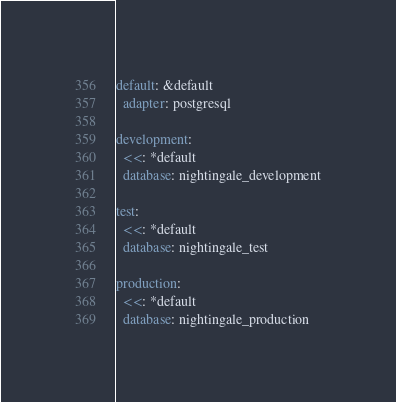Convert code to text. <code><loc_0><loc_0><loc_500><loc_500><_YAML_>default: &default
  adapter: postgresql

development:
  <<: *default
  database: nightingale_development

test:
  <<: *default
  database: nightingale_test

production:
  <<: *default
  database: nightingale_production
</code> 